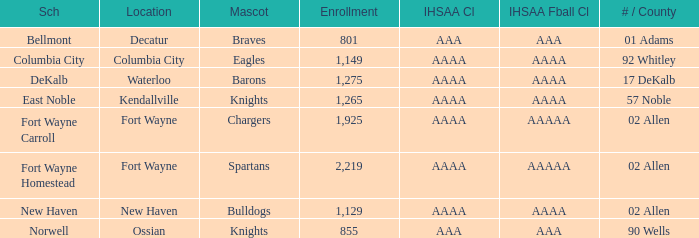What's the IHSAA Football Class in Decatur with an AAA IHSAA class? AAA. 